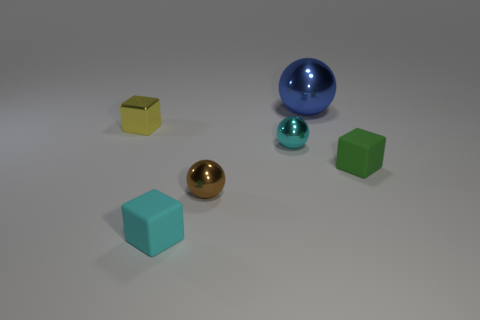Subtract all brown blocks. Subtract all purple cylinders. How many blocks are left? 3 Add 1 big metallic cylinders. How many objects exist? 7 Subtract all large blue metallic balls. Subtract all large blue metallic balls. How many objects are left? 4 Add 2 cyan metallic spheres. How many cyan metallic spheres are left? 3 Add 4 blue metal things. How many blue metal things exist? 5 Subtract 1 brown balls. How many objects are left? 5 